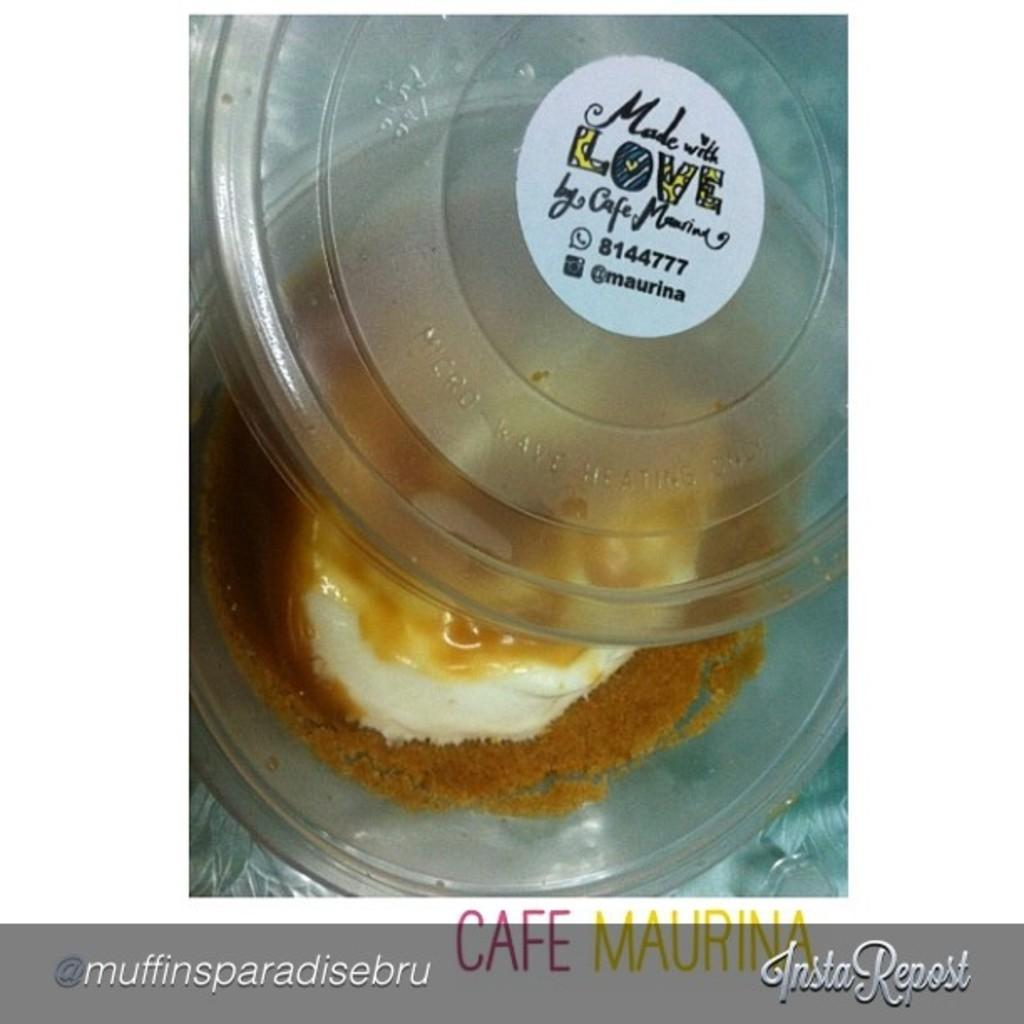What is in the bowl that is visible in the image? There is a bowl with food in the image. How is the bowl covered or protected? The bowl has a lid. What information can be found on the lid of the bowl? The lid has a label attached to it. What can be read or seen at the bottom of the image? There is text visible at the bottom of the image. How many brothers are depicted in the image? There are no brothers depicted in the image; it only features a bowl with food, a lid, and a label. 